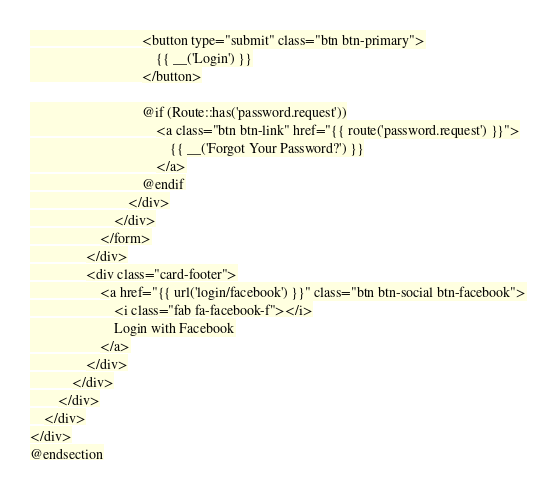Convert code to text. <code><loc_0><loc_0><loc_500><loc_500><_PHP_>                                <button type="submit" class="btn btn-primary">
                                    {{ __('Login') }}
                                </button>

                                @if (Route::has('password.request'))
                                    <a class="btn btn-link" href="{{ route('password.request') }}">
                                        {{ __('Forgot Your Password?') }}
                                    </a>
                                @endif
                            </div>
                        </div>
                    </form>
                </div>
                <div class="card-footer">
                    <a href="{{ url('login/facebook') }}" class="btn btn-social btn-facebook">
                        <i class="fab fa-facebook-f"></i>
                        Login with Facebook
                    </a>
                </div>
            </div>
        </div>
    </div>
</div>
@endsection
</code> 